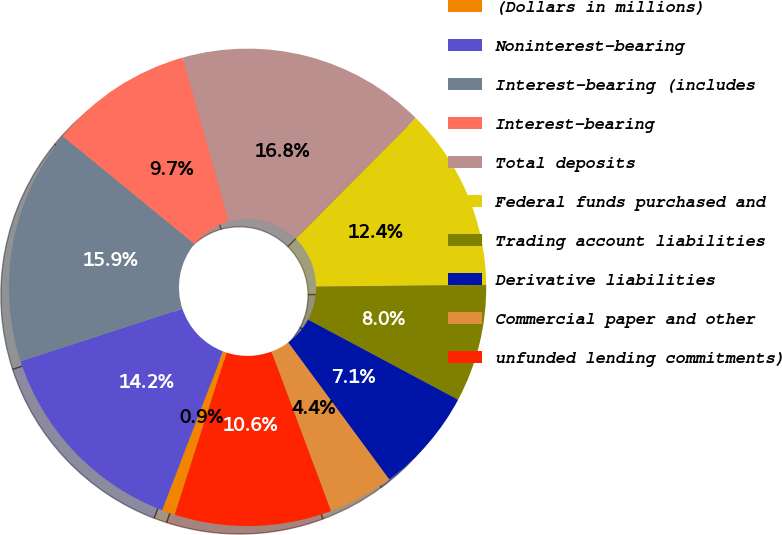Convert chart. <chart><loc_0><loc_0><loc_500><loc_500><pie_chart><fcel>(Dollars in millions)<fcel>Noninterest-bearing<fcel>Interest-bearing (includes<fcel>Interest-bearing<fcel>Total deposits<fcel>Federal funds purchased and<fcel>Trading account liabilities<fcel>Derivative liabilities<fcel>Commercial paper and other<fcel>unfunded lending commitments)<nl><fcel>0.89%<fcel>14.16%<fcel>15.93%<fcel>9.73%<fcel>16.81%<fcel>12.39%<fcel>7.97%<fcel>7.08%<fcel>4.43%<fcel>10.62%<nl></chart> 